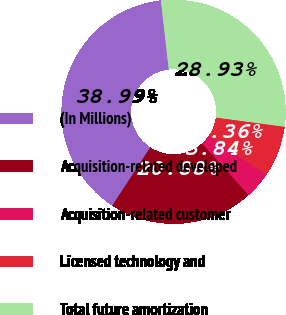Convert chart. <chart><loc_0><loc_0><loc_500><loc_500><pie_chart><fcel>(In Millions)<fcel>Acquisition-related developed<fcel>Acquisition-related customer<fcel>Licensed technology and<fcel>Total future amortization<nl><fcel>38.99%<fcel>20.88%<fcel>3.84%<fcel>7.36%<fcel>28.93%<nl></chart> 